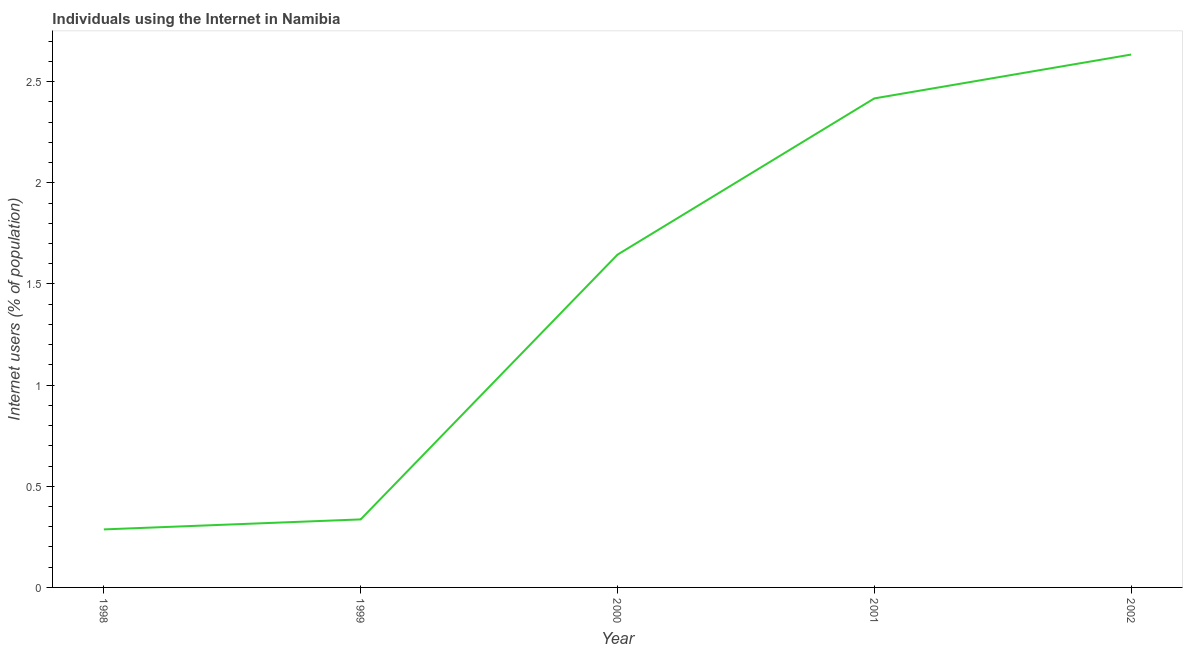What is the number of internet users in 1999?
Make the answer very short. 0.34. Across all years, what is the maximum number of internet users?
Your answer should be very brief. 2.63. Across all years, what is the minimum number of internet users?
Give a very brief answer. 0.29. In which year was the number of internet users maximum?
Provide a short and direct response. 2002. In which year was the number of internet users minimum?
Keep it short and to the point. 1998. What is the sum of the number of internet users?
Offer a very short reply. 7.32. What is the difference between the number of internet users in 2000 and 2002?
Provide a succinct answer. -0.99. What is the average number of internet users per year?
Offer a very short reply. 1.46. What is the median number of internet users?
Keep it short and to the point. 1.64. In how many years, is the number of internet users greater than 1 %?
Provide a short and direct response. 3. What is the ratio of the number of internet users in 1998 to that in 2000?
Provide a short and direct response. 0.17. Is the number of internet users in 1998 less than that in 1999?
Offer a terse response. Yes. What is the difference between the highest and the second highest number of internet users?
Ensure brevity in your answer.  0.22. What is the difference between the highest and the lowest number of internet users?
Give a very brief answer. 2.35. In how many years, is the number of internet users greater than the average number of internet users taken over all years?
Offer a terse response. 3. Does the number of internet users monotonically increase over the years?
Make the answer very short. Yes. What is the difference between two consecutive major ticks on the Y-axis?
Offer a terse response. 0.5. Does the graph contain grids?
Keep it short and to the point. No. What is the title of the graph?
Make the answer very short. Individuals using the Internet in Namibia. What is the label or title of the Y-axis?
Your response must be concise. Internet users (% of population). What is the Internet users (% of population) of 1998?
Your response must be concise. 0.29. What is the Internet users (% of population) of 1999?
Keep it short and to the point. 0.34. What is the Internet users (% of population) of 2000?
Give a very brief answer. 1.64. What is the Internet users (% of population) of 2001?
Ensure brevity in your answer.  2.42. What is the Internet users (% of population) in 2002?
Your answer should be compact. 2.63. What is the difference between the Internet users (% of population) in 1998 and 1999?
Provide a succinct answer. -0.05. What is the difference between the Internet users (% of population) in 1998 and 2000?
Ensure brevity in your answer.  -1.36. What is the difference between the Internet users (% of population) in 1998 and 2001?
Give a very brief answer. -2.13. What is the difference between the Internet users (% of population) in 1998 and 2002?
Provide a short and direct response. -2.35. What is the difference between the Internet users (% of population) in 1999 and 2000?
Provide a succinct answer. -1.31. What is the difference between the Internet users (% of population) in 1999 and 2001?
Keep it short and to the point. -2.08. What is the difference between the Internet users (% of population) in 1999 and 2002?
Your response must be concise. -2.3. What is the difference between the Internet users (% of population) in 2000 and 2001?
Your answer should be very brief. -0.77. What is the difference between the Internet users (% of population) in 2000 and 2002?
Ensure brevity in your answer.  -0.99. What is the difference between the Internet users (% of population) in 2001 and 2002?
Your answer should be very brief. -0.22. What is the ratio of the Internet users (% of population) in 1998 to that in 1999?
Offer a terse response. 0.85. What is the ratio of the Internet users (% of population) in 1998 to that in 2000?
Offer a terse response. 0.17. What is the ratio of the Internet users (% of population) in 1998 to that in 2001?
Provide a short and direct response. 0.12. What is the ratio of the Internet users (% of population) in 1998 to that in 2002?
Make the answer very short. 0.11. What is the ratio of the Internet users (% of population) in 1999 to that in 2000?
Ensure brevity in your answer.  0.2. What is the ratio of the Internet users (% of population) in 1999 to that in 2001?
Your answer should be compact. 0.14. What is the ratio of the Internet users (% of population) in 1999 to that in 2002?
Offer a very short reply. 0.13. What is the ratio of the Internet users (% of population) in 2000 to that in 2001?
Your answer should be very brief. 0.68. What is the ratio of the Internet users (% of population) in 2000 to that in 2002?
Provide a short and direct response. 0.62. What is the ratio of the Internet users (% of population) in 2001 to that in 2002?
Your answer should be compact. 0.92. 